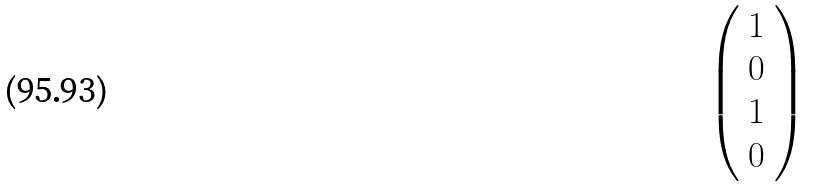<formula> <loc_0><loc_0><loc_500><loc_500>\left ( \begin{array} { l } { 1 } \\ { 0 } \\ { 1 } \\ { 0 } \end{array} \right )</formula> 